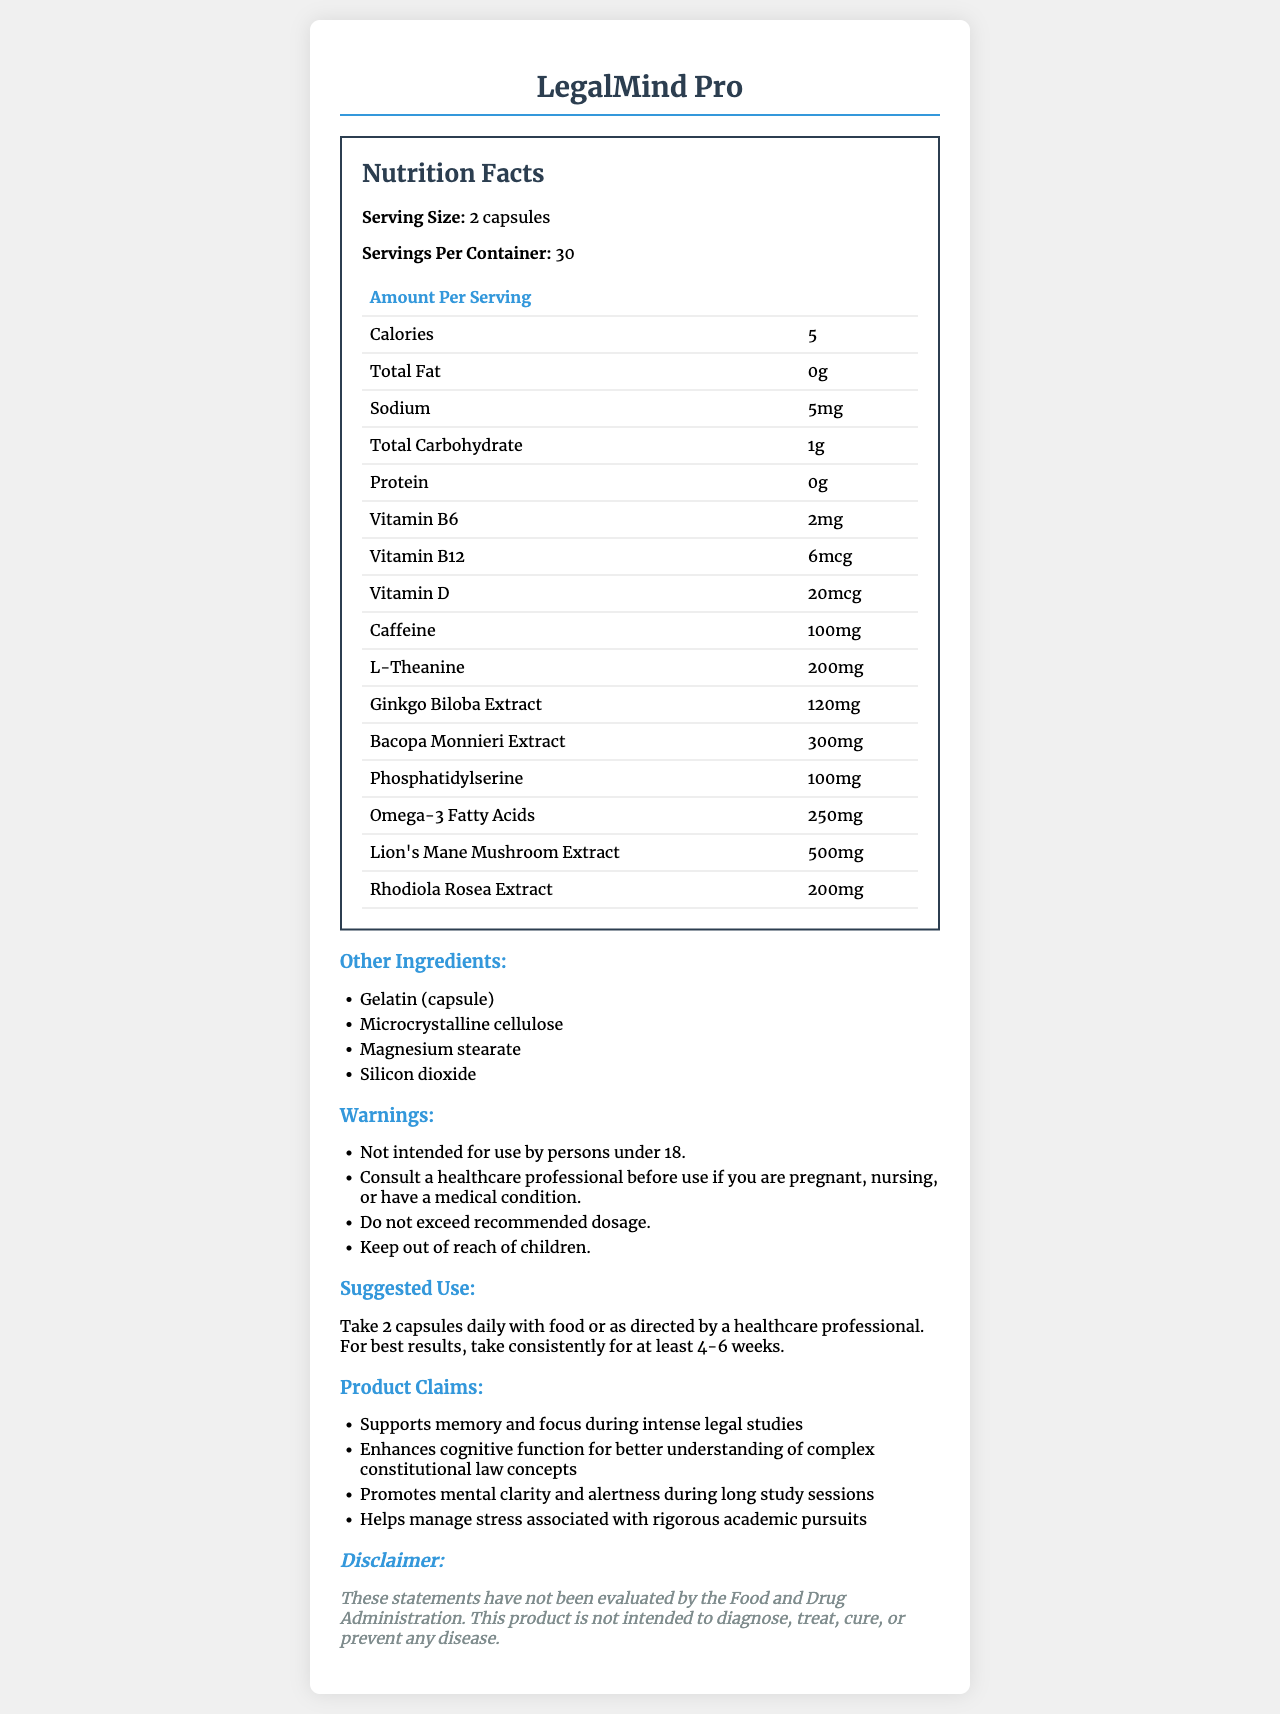what is the serving size of LegalMind Pro? The serving size is clearly listed as "2 capsules" in the nutrition facts section of the document.
Answer: 2 capsules how many servings are there per container? The document states that there are 30 servings per container.
Answer: 30 how much caffeine is in each serving? The nutrition facts table shows that each serving contains 100mg of caffeine.
Answer: 100mg list two ingredients aside from the main active ingredients. The "Other Ingredients" section lists Gelatin (capsule) and Microcrystalline cellulose among others.
Answer: Gelatin (capsule), Microcrystalline cellulose what is the suggested daily intake for best results? The suggested use section recommends taking 2 capsules daily with food and maintaining the routine for at least 4-6 weeks for best results.
Answer: 2 capsules daily with food, consistently for at least 4-6 weeks does LegalMind Pro contain any fats? The nutrition facts indicate "Total Fat: 0g", meaning it contains no fats.
Answer: No is vitamin B12 present in the supplement? The nutrition facts include Vitamin B12, amounting to 6mcg per serving.
Answer: Yes how many calories are in a serving? A. 0 B. 5 C. 10 D. 20 The nutrition facts display that each serving contains 5 calories.
Answer: B what is the main purpose of LegalMind Pro according to its marketing claims? A. Weight Loss B. Enhanced Cognitive Function C. Muscle Gain D. Improved Digestion The marketing claims section mentions enhancing cognitive function, supporting memory and focus, and promoting mental clarity which fits option B.
Answer: B is this product evaluated by the FDA? The disclaimer states that the statements have not been evaluated by the Food and Drug Administration.
Answer: No summarize the main idea of the document The document provides detailed nutritional information, the suggested use, ingredients, and marketing claims for a cognitive support supplement named LegalMind Pro, targeting legal studies enhancement.
Answer: LegalMind Pro is a brain-boosting supplement designed to enhance cognitive function, memory, and focus during intense legal studies. It provides 2 capsules per daily serving with ingredients such as caffeine, L-theanine, and multiple herbal extracts. The supplement is not FDA-evaluated and contains instructions, warnings, and marketing claims focused on academic performance. who is the manufacturer of LegalMind Pro? The document does not provide any information on the manufacturer of LegalMind Pro.
Answer: Cannot be determined 